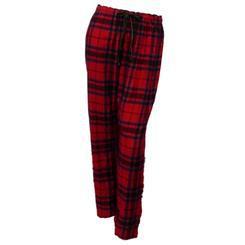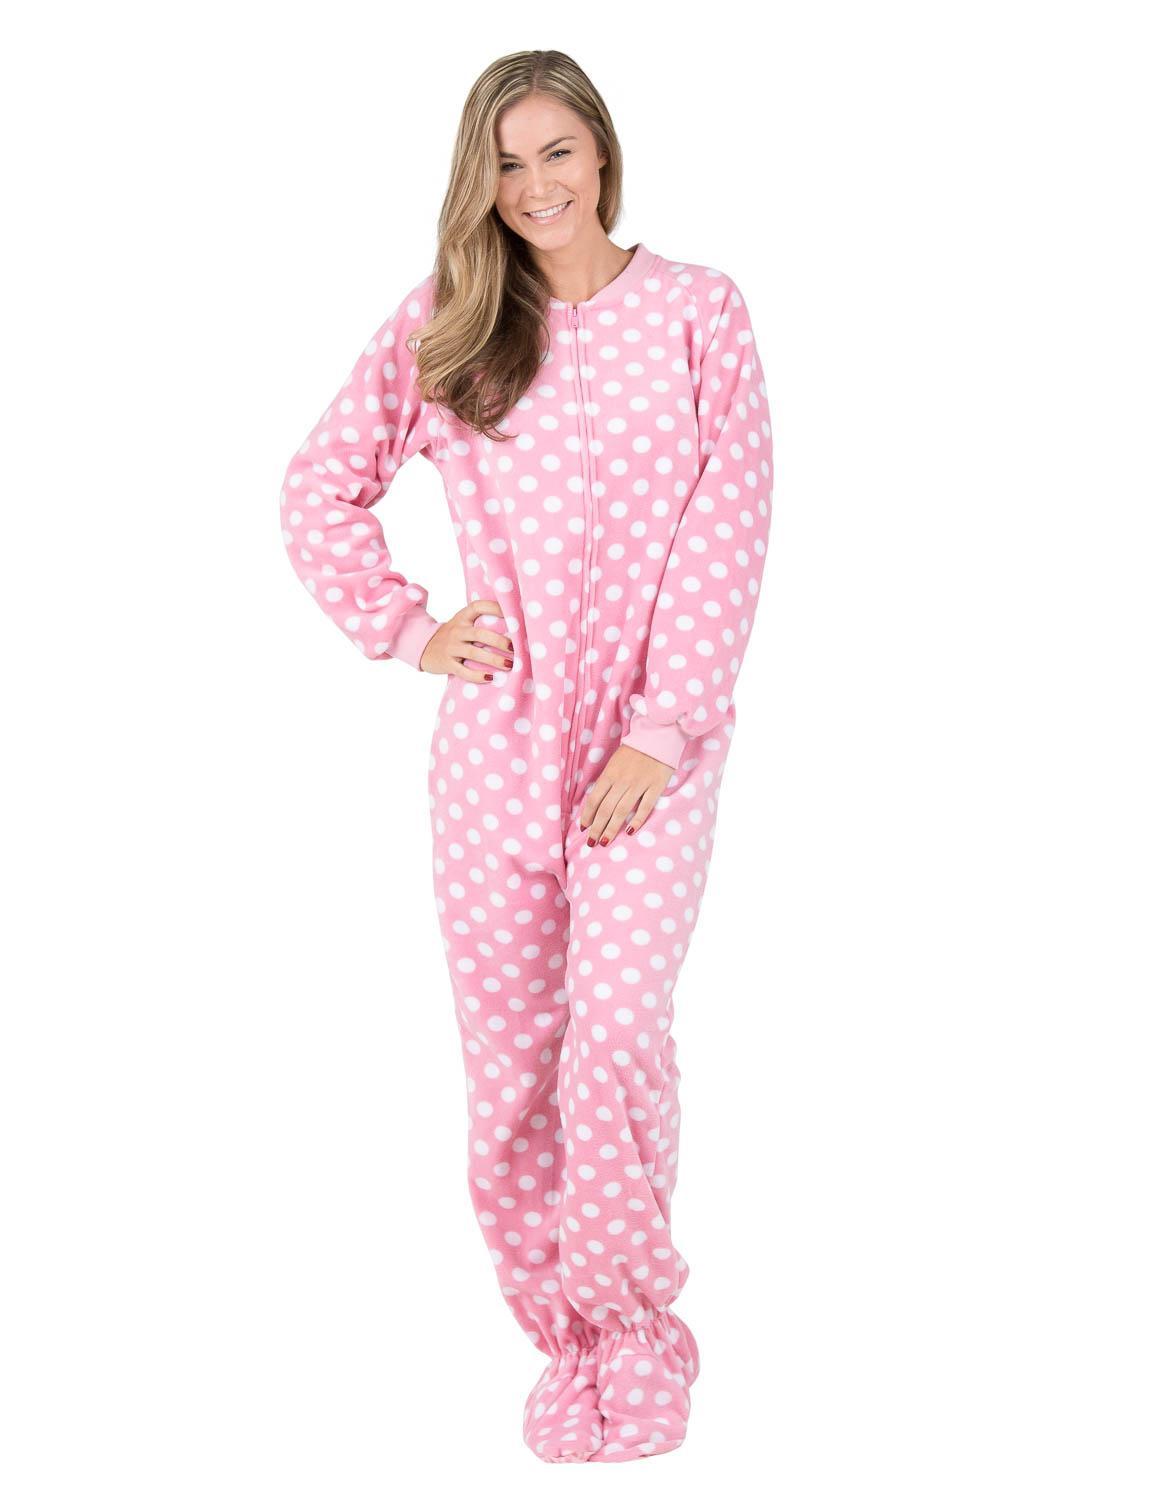The first image is the image on the left, the second image is the image on the right. Evaluate the accuracy of this statement regarding the images: "There is a woman with her hand on her hips and her shoulder sticking out.". Is it true? Answer yes or no. Yes. 